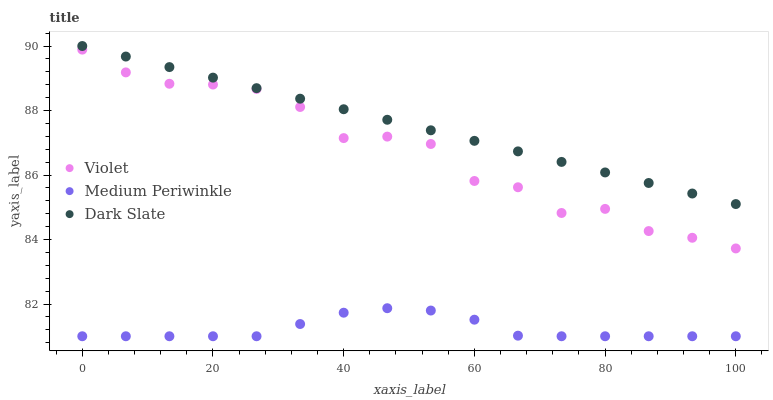Does Medium Periwinkle have the minimum area under the curve?
Answer yes or no. Yes. Does Dark Slate have the maximum area under the curve?
Answer yes or no. Yes. Does Violet have the minimum area under the curve?
Answer yes or no. No. Does Violet have the maximum area under the curve?
Answer yes or no. No. Is Dark Slate the smoothest?
Answer yes or no. Yes. Is Violet the roughest?
Answer yes or no. Yes. Is Medium Periwinkle the smoothest?
Answer yes or no. No. Is Medium Periwinkle the roughest?
Answer yes or no. No. Does Medium Periwinkle have the lowest value?
Answer yes or no. Yes. Does Violet have the lowest value?
Answer yes or no. No. Does Dark Slate have the highest value?
Answer yes or no. Yes. Does Violet have the highest value?
Answer yes or no. No. Is Medium Periwinkle less than Violet?
Answer yes or no. Yes. Is Dark Slate greater than Medium Periwinkle?
Answer yes or no. Yes. Does Medium Periwinkle intersect Violet?
Answer yes or no. No. 